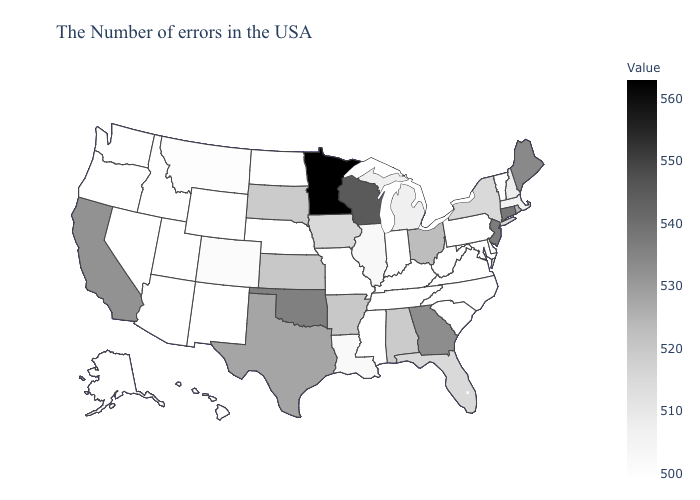Does the map have missing data?
Give a very brief answer. No. Among the states that border Colorado , which have the highest value?
Concise answer only. Oklahoma. Does North Carolina have the lowest value in the South?
Short answer required. Yes. 